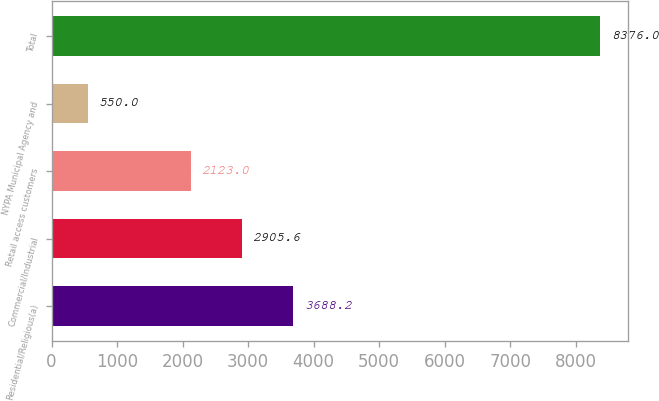Convert chart to OTSL. <chart><loc_0><loc_0><loc_500><loc_500><bar_chart><fcel>Residential/Religious(a)<fcel>Commercial/Industrial<fcel>Retail access customers<fcel>NYPA Municipal Agency and<fcel>Total<nl><fcel>3688.2<fcel>2905.6<fcel>2123<fcel>550<fcel>8376<nl></chart> 